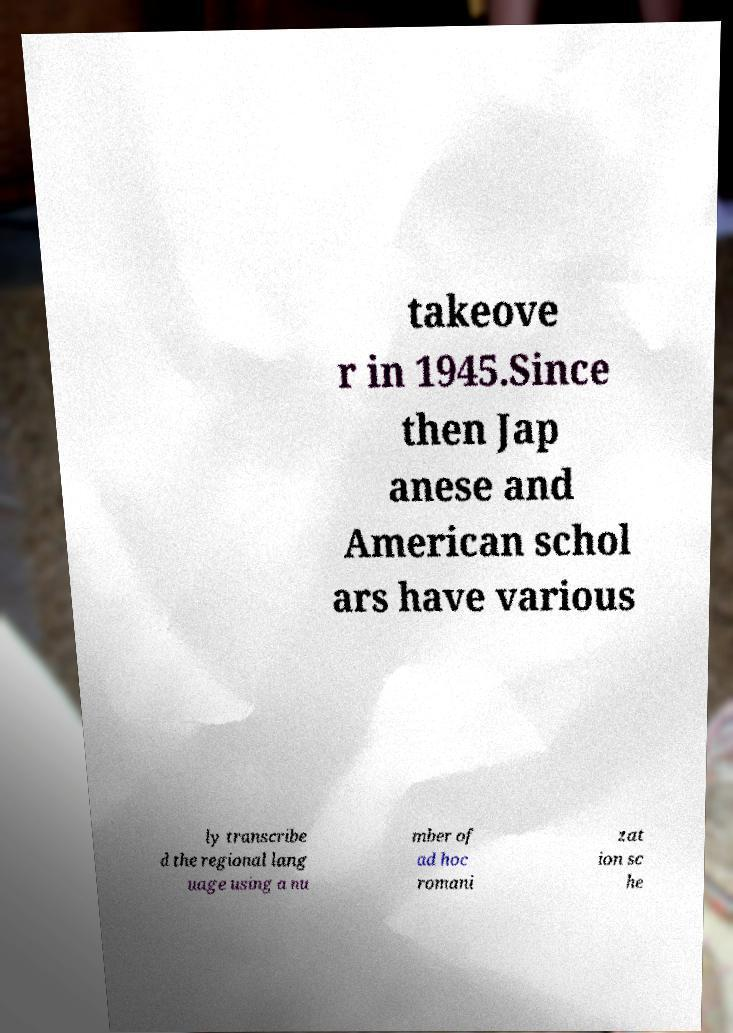What messages or text are displayed in this image? I need them in a readable, typed format. takeove r in 1945.Since then Jap anese and American schol ars have various ly transcribe d the regional lang uage using a nu mber of ad hoc romani zat ion sc he 